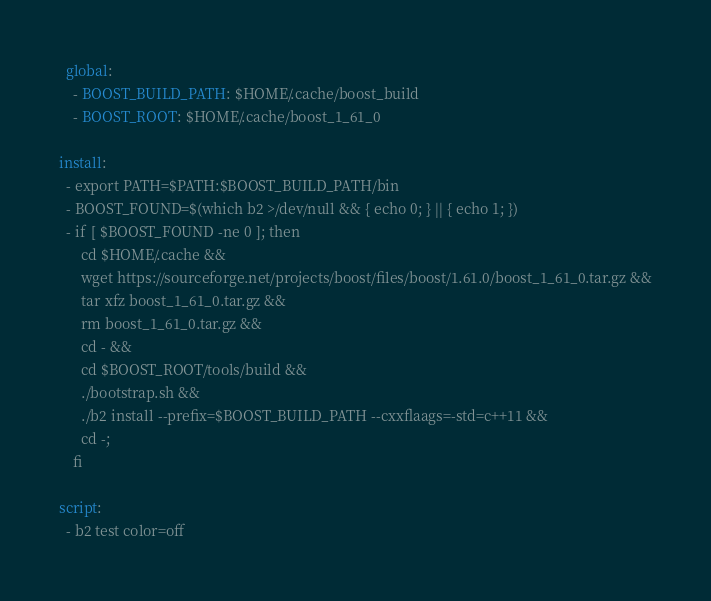<code> <loc_0><loc_0><loc_500><loc_500><_YAML_>  global:
    - BOOST_BUILD_PATH: $HOME/.cache/boost_build
    - BOOST_ROOT: $HOME/.cache/boost_1_61_0

install:
  - export PATH=$PATH:$BOOST_BUILD_PATH/bin
  - BOOST_FOUND=$(which b2 >/dev/null && { echo 0; } || { echo 1; })
  - if [ $BOOST_FOUND -ne 0 ]; then
      cd $HOME/.cache &&
      wget https://sourceforge.net/projects/boost/files/boost/1.61.0/boost_1_61_0.tar.gz &&
      tar xfz boost_1_61_0.tar.gz &&
      rm boost_1_61_0.tar.gz &&
      cd - &&
      cd $BOOST_ROOT/tools/build &&
      ./bootstrap.sh &&
      ./b2 install --prefix=$BOOST_BUILD_PATH --cxxflaags=-std=c++11 &&
      cd -;
    fi

script:
  - b2 test color=off

</code> 